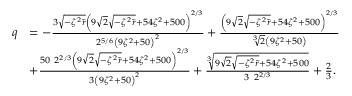<formula> <loc_0><loc_0><loc_500><loc_500>\begin{array} { r l } { q } & { = - \frac { 3 \sqrt { - \zeta ^ { 2 } \tilde { r } } \left ( 9 \sqrt { 2 } \sqrt { - \zeta ^ { 2 } \tilde { r } } + 5 4 \zeta ^ { 2 } + 5 0 0 \right ) ^ { 2 / 3 } } { 2 ^ { 5 / 6 } \left ( 9 \zeta ^ { 2 } + 5 0 \right ) ^ { 2 } } + \frac { \left ( 9 \sqrt { 2 } \sqrt { - \zeta ^ { 2 } \tilde { r } } + 5 4 \zeta ^ { 2 } + 5 0 0 \right ) ^ { 2 / 3 } } { \sqrt { [ } 3 ] { 2 } \left ( 9 \zeta ^ { 2 } + 5 0 \right ) } } \\ & { + \frac { 5 0 \ 2 ^ { 2 / 3 } \left ( 9 \sqrt { 2 } \sqrt { - \zeta ^ { 2 } \tilde { r } } + 5 4 \zeta ^ { 2 } + 5 0 0 \right ) ^ { 2 / 3 } } { 3 \left ( 9 \zeta ^ { 2 } + 5 0 \right ) ^ { 2 } } + \frac { \sqrt { [ } 3 ] { 9 \sqrt { 2 } \sqrt { - \zeta ^ { 2 } \tilde { r } } + 5 4 \zeta ^ { 2 } + 5 0 0 } } { 3 \ 2 ^ { 2 / 3 } } + \frac { 2 } { 3 } . } \end{array}</formula> 